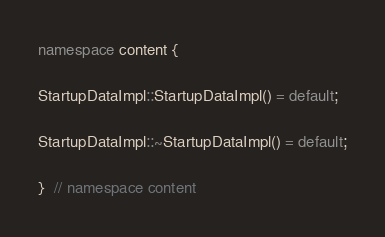Convert code to text. <code><loc_0><loc_0><loc_500><loc_500><_C++_>
namespace content {

StartupDataImpl::StartupDataImpl() = default;

StartupDataImpl::~StartupDataImpl() = default;

}  // namespace content
</code> 